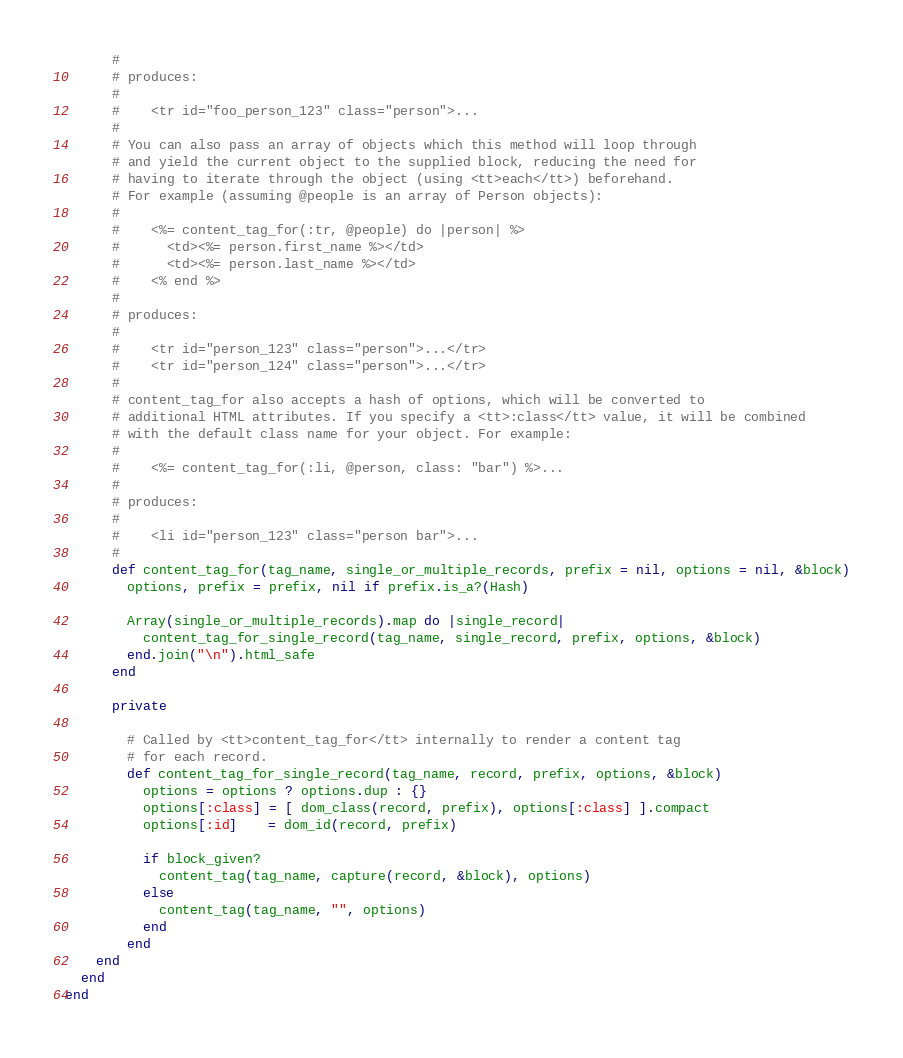Convert code to text. <code><loc_0><loc_0><loc_500><loc_500><_Ruby_>      #
      # produces:
      #
      #    <tr id="foo_person_123" class="person">...
      #
      # You can also pass an array of objects which this method will loop through
      # and yield the current object to the supplied block, reducing the need for
      # having to iterate through the object (using <tt>each</tt>) beforehand.
      # For example (assuming @people is an array of Person objects):
      #
      #    <%= content_tag_for(:tr, @people) do |person| %>
      #      <td><%= person.first_name %></td>
      #      <td><%= person.last_name %></td>
      #    <% end %>
      #
      # produces:
      #
      #    <tr id="person_123" class="person">...</tr>
      #    <tr id="person_124" class="person">...</tr>
      #
      # content_tag_for also accepts a hash of options, which will be converted to
      # additional HTML attributes. If you specify a <tt>:class</tt> value, it will be combined
      # with the default class name for your object. For example:
      #
      #    <%= content_tag_for(:li, @person, class: "bar") %>...
      #
      # produces:
      #
      #    <li id="person_123" class="person bar">...
      #
      def content_tag_for(tag_name, single_or_multiple_records, prefix = nil, options = nil, &block)
        options, prefix = prefix, nil if prefix.is_a?(Hash)

        Array(single_or_multiple_records).map do |single_record|
          content_tag_for_single_record(tag_name, single_record, prefix, options, &block)
        end.join("\n").html_safe
      end

      private

        # Called by <tt>content_tag_for</tt> internally to render a content tag
        # for each record.
        def content_tag_for_single_record(tag_name, record, prefix, options, &block)
          options = options ? options.dup : {}
          options[:class] = [ dom_class(record, prefix), options[:class] ].compact
          options[:id]    = dom_id(record, prefix)

          if block_given?
            content_tag(tag_name, capture(record, &block), options)
          else
            content_tag(tag_name, "", options)
          end
        end
    end
  end
end
</code> 